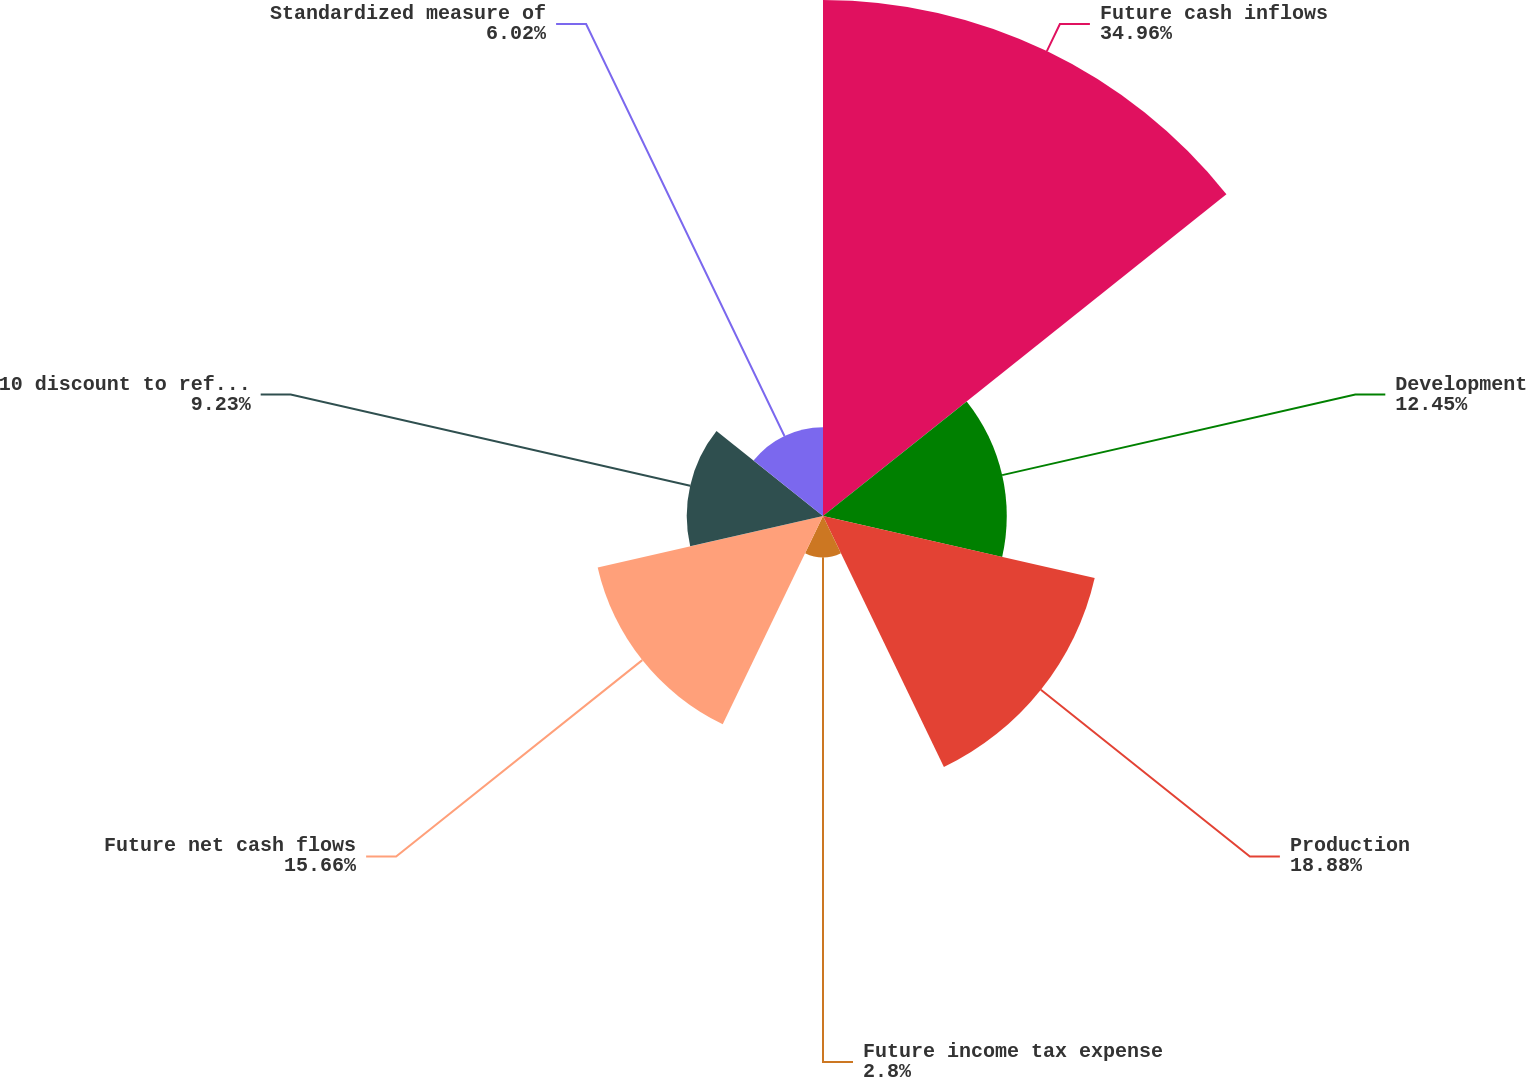Convert chart. <chart><loc_0><loc_0><loc_500><loc_500><pie_chart><fcel>Future cash inflows<fcel>Development<fcel>Production<fcel>Future income tax expense<fcel>Future net cash flows<fcel>10 discount to reflect timing<fcel>Standardized measure of<nl><fcel>34.96%<fcel>12.45%<fcel>18.88%<fcel>2.8%<fcel>15.66%<fcel>9.23%<fcel>6.02%<nl></chart> 